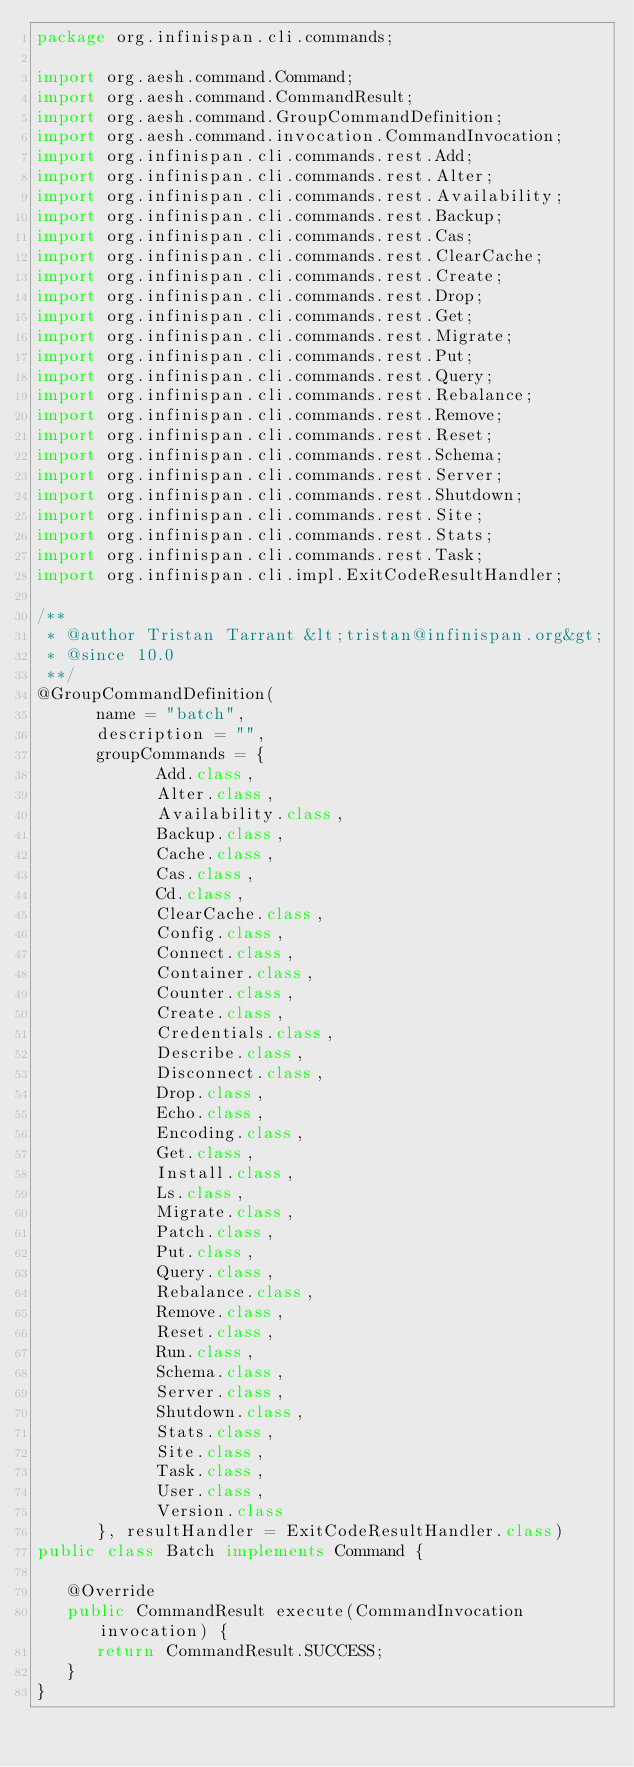<code> <loc_0><loc_0><loc_500><loc_500><_Java_>package org.infinispan.cli.commands;

import org.aesh.command.Command;
import org.aesh.command.CommandResult;
import org.aesh.command.GroupCommandDefinition;
import org.aesh.command.invocation.CommandInvocation;
import org.infinispan.cli.commands.rest.Add;
import org.infinispan.cli.commands.rest.Alter;
import org.infinispan.cli.commands.rest.Availability;
import org.infinispan.cli.commands.rest.Backup;
import org.infinispan.cli.commands.rest.Cas;
import org.infinispan.cli.commands.rest.ClearCache;
import org.infinispan.cli.commands.rest.Create;
import org.infinispan.cli.commands.rest.Drop;
import org.infinispan.cli.commands.rest.Get;
import org.infinispan.cli.commands.rest.Migrate;
import org.infinispan.cli.commands.rest.Put;
import org.infinispan.cli.commands.rest.Query;
import org.infinispan.cli.commands.rest.Rebalance;
import org.infinispan.cli.commands.rest.Remove;
import org.infinispan.cli.commands.rest.Reset;
import org.infinispan.cli.commands.rest.Schema;
import org.infinispan.cli.commands.rest.Server;
import org.infinispan.cli.commands.rest.Shutdown;
import org.infinispan.cli.commands.rest.Site;
import org.infinispan.cli.commands.rest.Stats;
import org.infinispan.cli.commands.rest.Task;
import org.infinispan.cli.impl.ExitCodeResultHandler;

/**
 * @author Tristan Tarrant &lt;tristan@infinispan.org&gt;
 * @since 10.0
 **/
@GroupCommandDefinition(
      name = "batch",
      description = "",
      groupCommands = {
            Add.class,
            Alter.class,
            Availability.class,
            Backup.class,
            Cache.class,
            Cas.class,
            Cd.class,
            ClearCache.class,
            Config.class,
            Connect.class,
            Container.class,
            Counter.class,
            Create.class,
            Credentials.class,
            Describe.class,
            Disconnect.class,
            Drop.class,
            Echo.class,
            Encoding.class,
            Get.class,
            Install.class,
            Ls.class,
            Migrate.class,
            Patch.class,
            Put.class,
            Query.class,
            Rebalance.class,
            Remove.class,
            Reset.class,
            Run.class,
            Schema.class,
            Server.class,
            Shutdown.class,
            Stats.class,
            Site.class,
            Task.class,
            User.class,
            Version.class
      }, resultHandler = ExitCodeResultHandler.class)
public class Batch implements Command {

   @Override
   public CommandResult execute(CommandInvocation invocation) {
      return CommandResult.SUCCESS;
   }
}
</code> 